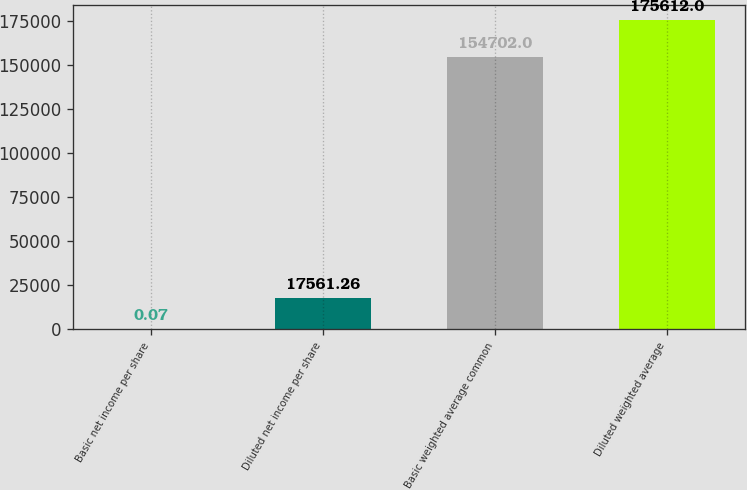<chart> <loc_0><loc_0><loc_500><loc_500><bar_chart><fcel>Basic net income per share<fcel>Diluted net income per share<fcel>Basic weighted average common<fcel>Diluted weighted average<nl><fcel>0.07<fcel>17561.3<fcel>154702<fcel>175612<nl></chart> 